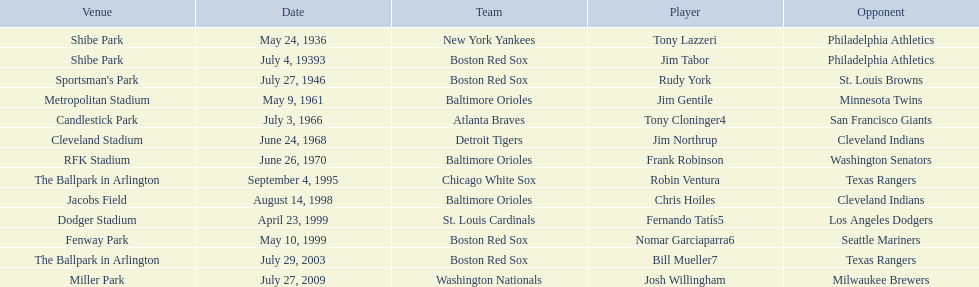Who were all the teams? New York Yankees, Boston Red Sox, Boston Red Sox, Baltimore Orioles, Atlanta Braves, Detroit Tigers, Baltimore Orioles, Chicago White Sox, Baltimore Orioles, St. Louis Cardinals, Boston Red Sox, Boston Red Sox, Washington Nationals. What about opponents? Philadelphia Athletics, Philadelphia Athletics, St. Louis Browns, Minnesota Twins, San Francisco Giants, Cleveland Indians, Washington Senators, Texas Rangers, Cleveland Indians, Los Angeles Dodgers, Seattle Mariners, Texas Rangers, Milwaukee Brewers. And when did they play? May 24, 1936, July 4, 19393, July 27, 1946, May 9, 1961, July 3, 1966, June 24, 1968, June 26, 1970, September 4, 1995, August 14, 1998, April 23, 1999, May 10, 1999, July 29, 2003, July 27, 2009. Which team played the red sox on july 27, 1946	? St. Louis Browns. 